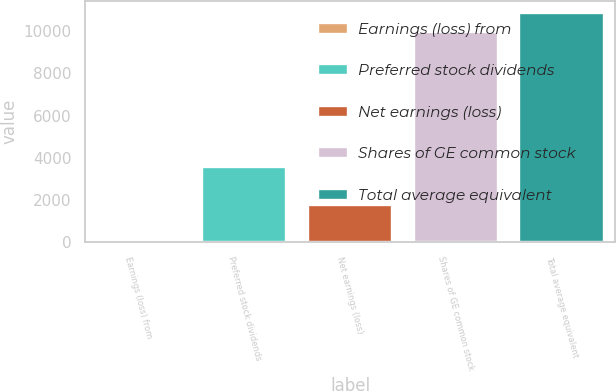Convert chart. <chart><loc_0><loc_0><loc_500><loc_500><bar_chart><fcel>Earnings (loss) from<fcel>Preferred stock dividends<fcel>Net earnings (loss)<fcel>Shares of GE common stock<fcel>Total average equivalent<nl><fcel>0.04<fcel>3577.64<fcel>1788.84<fcel>9981.8<fcel>10876.2<nl></chart> 